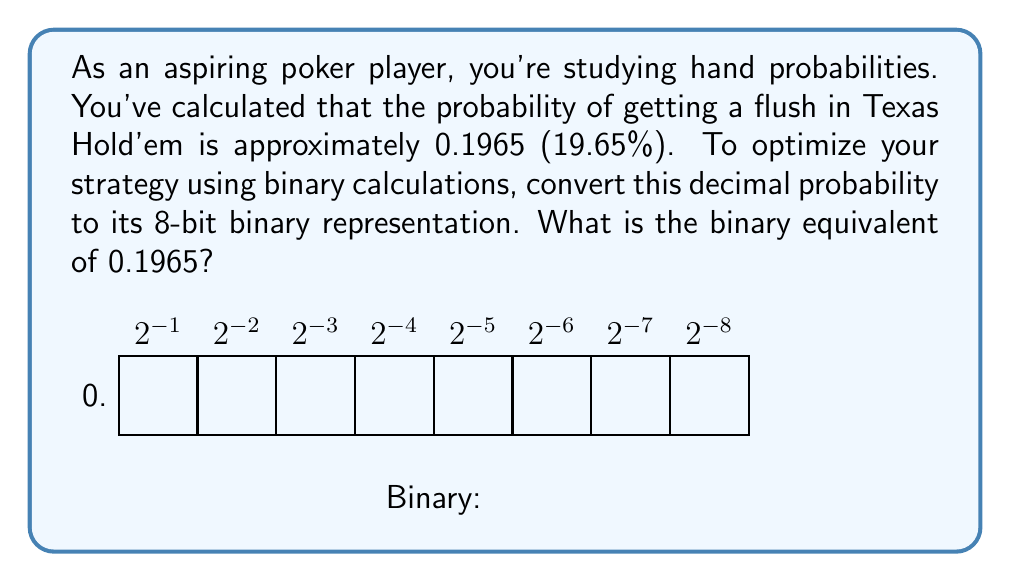Teach me how to tackle this problem. To convert 0.1965 to binary, we'll use the following steps:

1) Multiply the decimal by 2.
2) Take the integer part (0 or 1) as the binary digit.
3) Keep the fractional part and repeat steps 1-2 until we get 8 bits or the fraction becomes 0.

Let's begin:

$$0.1965 \times 2 = 0.3930 \rightarrow 0$$
$$0.3930 \times 2 = 0.7860 \rightarrow 0$$
$$0.7860 \times 2 = 1.5720 \rightarrow 1$$
$$0.5720 \times 2 = 1.1440 \rightarrow 1$$
$$0.1440 \times 2 = 0.2880 \rightarrow 0$$
$$0.2880 \times 2 = 0.5760 \rightarrow 0$$
$$0.5760 \times 2 = 1.1520 \rightarrow 1$$
$$0.1520 \times 2 = 0.3040 \rightarrow 0$$

Reading the integer parts from top to bottom gives us the binary representation: 0.00110010

Note: This is an approximation, as some decimal fractions cannot be exactly represented in binary with a finite number of bits.
Answer: 0.00110010 